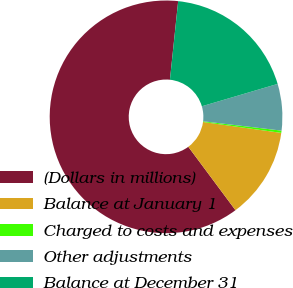<chart> <loc_0><loc_0><loc_500><loc_500><pie_chart><fcel>(Dollars in millions)<fcel>Balance at January 1<fcel>Charged to costs and expenses<fcel>Other adjustments<fcel>Balance at December 31<nl><fcel>61.84%<fcel>12.62%<fcel>0.31%<fcel>6.46%<fcel>18.77%<nl></chart> 